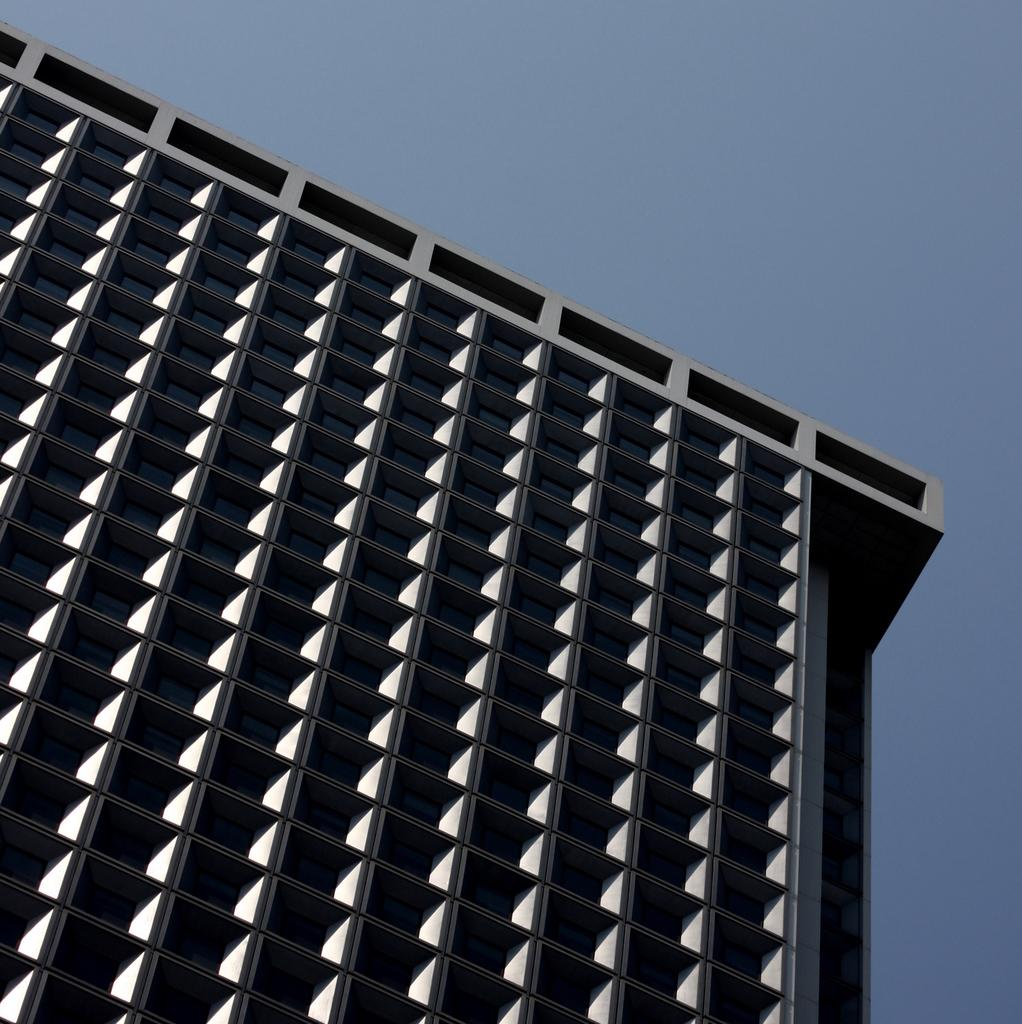What type of structure is present in the image? There is a building in the image. What can be seen in the background of the image? The sky is visible in the background of the image. Where is the scarecrow located in the image? There is no scarecrow present in the image. What type of animal can be seen interacting with the building in the image? There is no animal present in the image; it only features a building and the sky. 